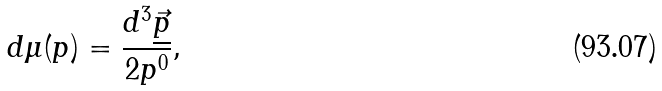<formula> <loc_0><loc_0><loc_500><loc_500>d \mu ( p ) = \frac { d ^ { 3 } \underline { \vec { p } } } { 2 p ^ { 0 } } ,</formula> 